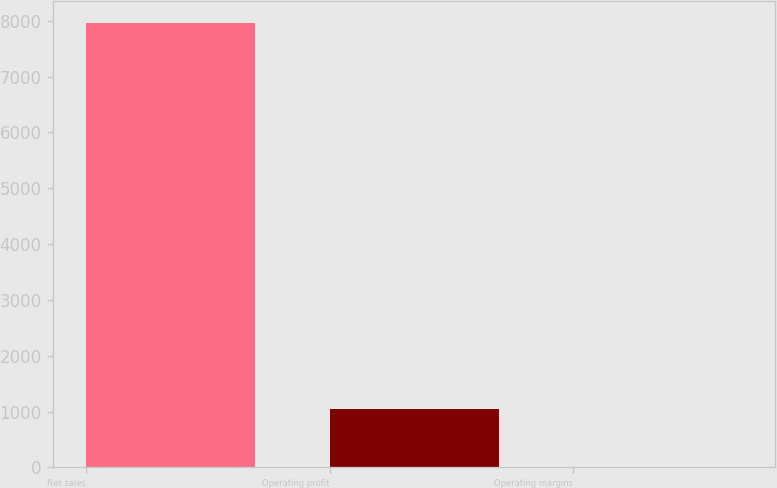Convert chart. <chart><loc_0><loc_0><loc_500><loc_500><bar_chart><fcel>Net sales<fcel>Operating profit<fcel>Operating margins<nl><fcel>7958<fcel>1045<fcel>13.1<nl></chart> 